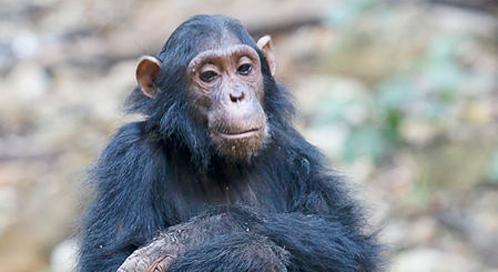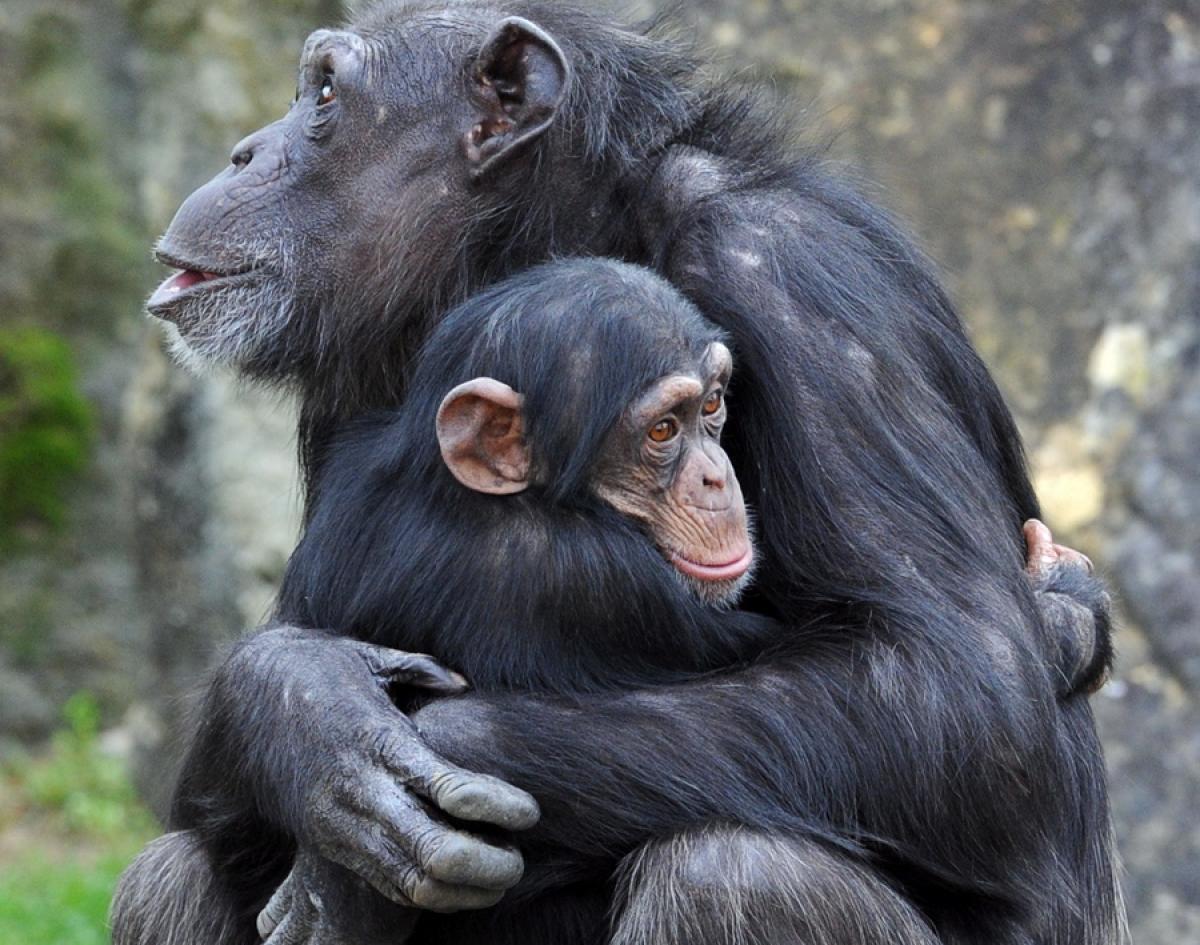The first image is the image on the left, the second image is the image on the right. For the images displayed, is the sentence "One monkey is holding another in one of the images." factually correct? Answer yes or no. Yes. 